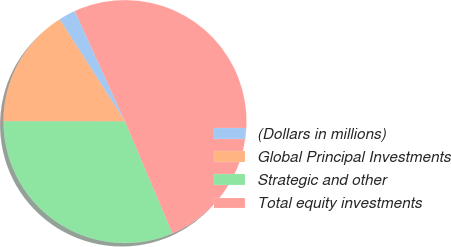<chart> <loc_0><loc_0><loc_500><loc_500><pie_chart><fcel>(Dollars in millions)<fcel>Global Principal Investments<fcel>Strategic and other<fcel>Total equity investments<nl><fcel>2.27%<fcel>15.89%<fcel>31.43%<fcel>50.41%<nl></chart> 